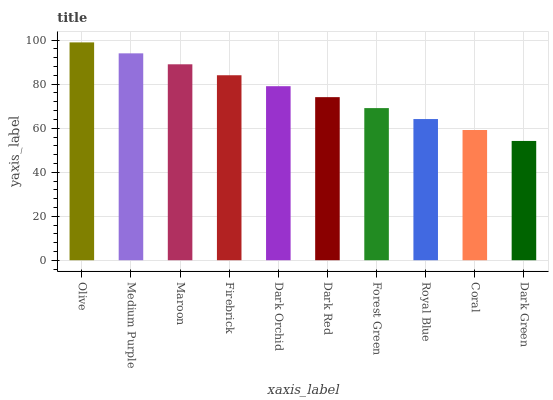Is Dark Green the minimum?
Answer yes or no. Yes. Is Olive the maximum?
Answer yes or no. Yes. Is Medium Purple the minimum?
Answer yes or no. No. Is Medium Purple the maximum?
Answer yes or no. No. Is Olive greater than Medium Purple?
Answer yes or no. Yes. Is Medium Purple less than Olive?
Answer yes or no. Yes. Is Medium Purple greater than Olive?
Answer yes or no. No. Is Olive less than Medium Purple?
Answer yes or no. No. Is Dark Orchid the high median?
Answer yes or no. Yes. Is Dark Red the low median?
Answer yes or no. Yes. Is Coral the high median?
Answer yes or no. No. Is Maroon the low median?
Answer yes or no. No. 